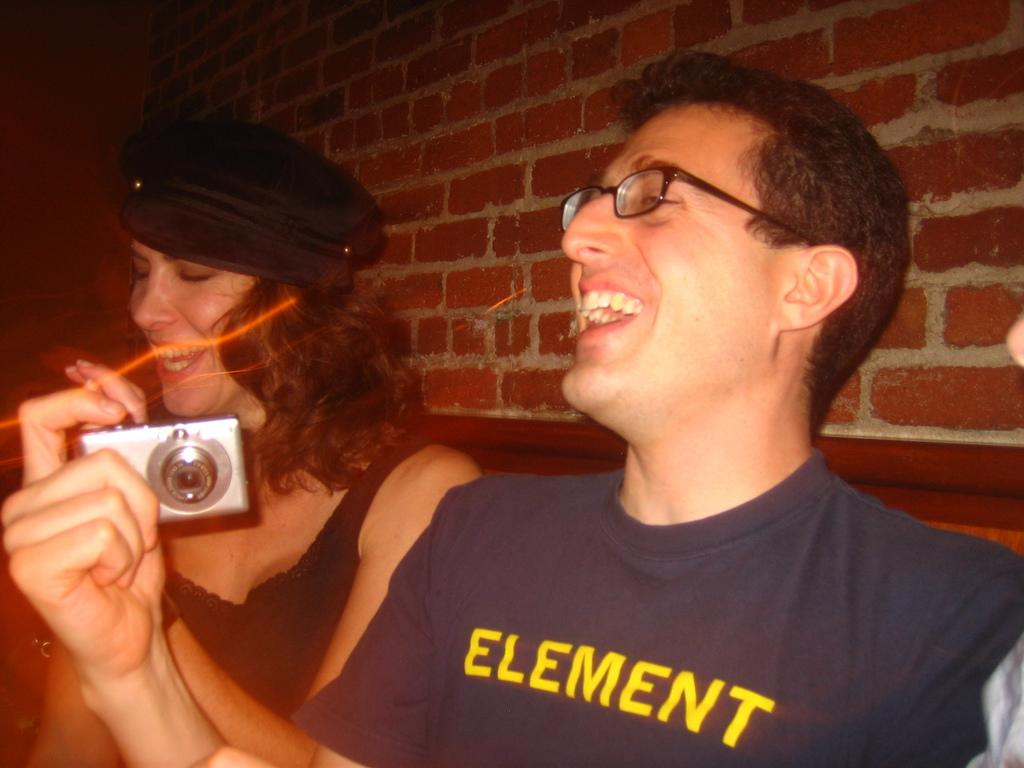What is the man in the image doing? The man is smiling in the image. What is the man holding in the image? The man is holding a camera in the image. What is the woman in the image doing? The woman is smiling in the image. What is the woman wearing in the image? The woman is wearing a cap in the image. What can be seen in the background of the image? There is a brick wall in the background of the image. How many pencils are visible in the image? There are no pencils visible in the image. What type of frogs can be seen in the image? There are no frogs present in the image. 